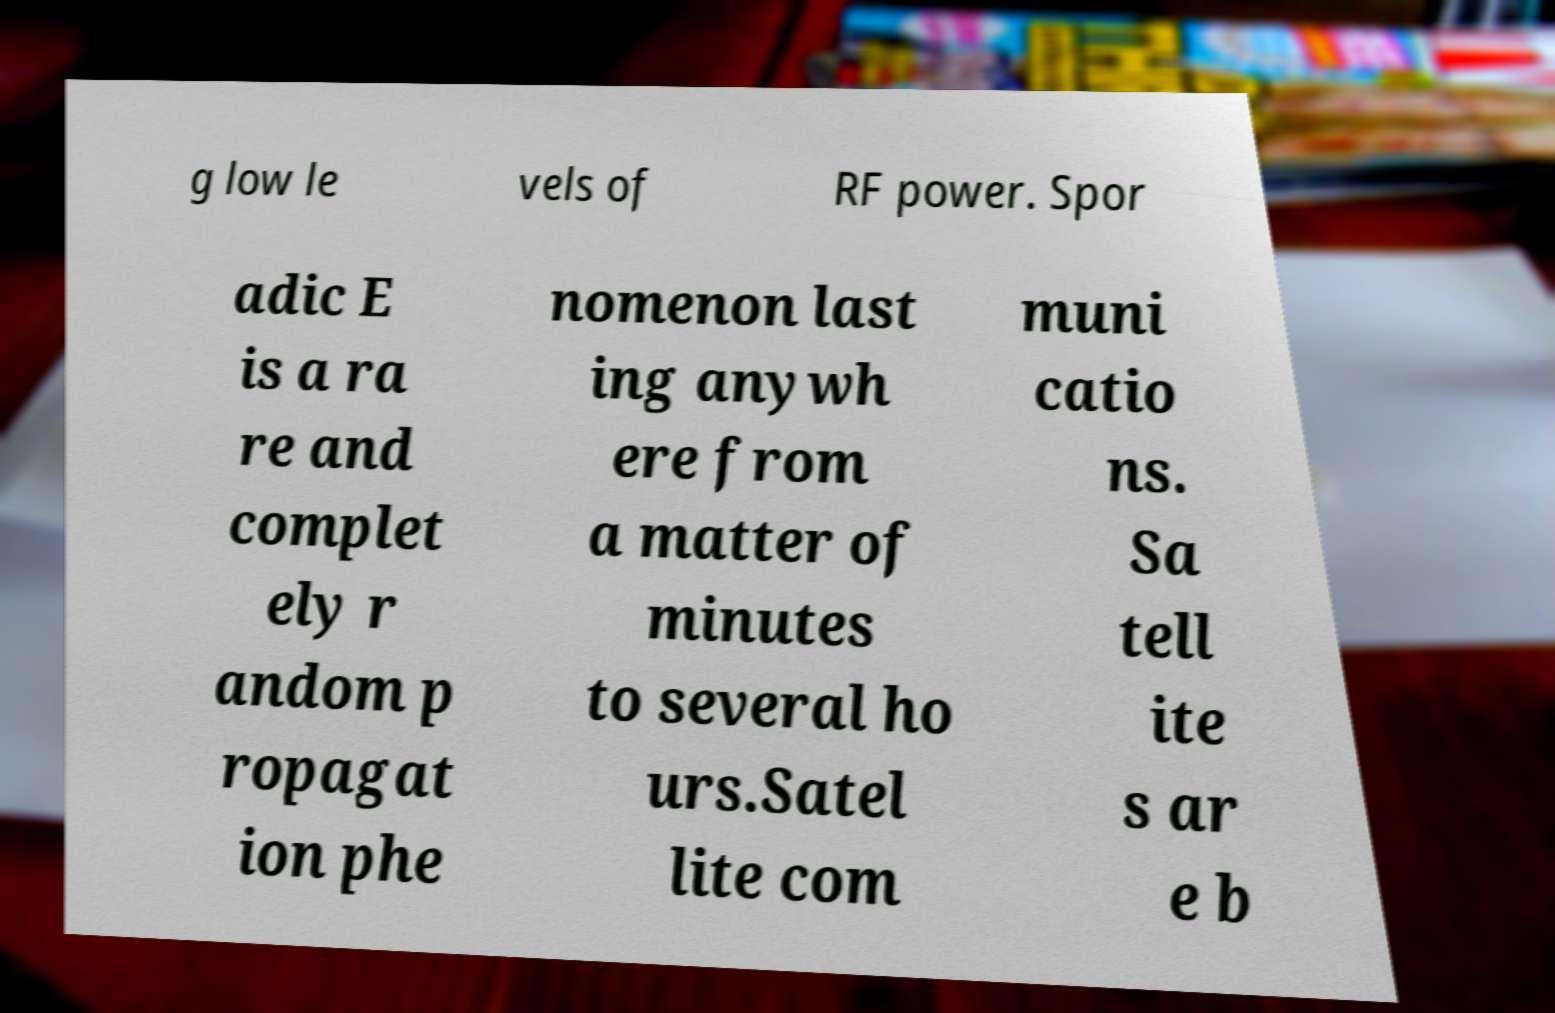Please identify and transcribe the text found in this image. g low le vels of RF power. Spor adic E is a ra re and complet ely r andom p ropagat ion phe nomenon last ing anywh ere from a matter of minutes to several ho urs.Satel lite com muni catio ns. Sa tell ite s ar e b 